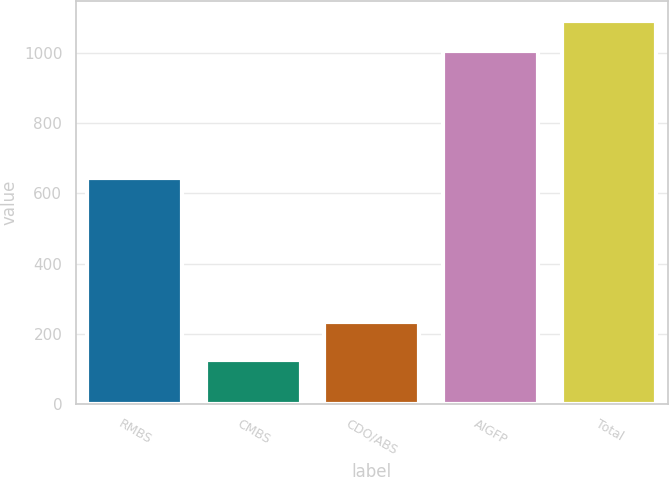<chart> <loc_0><loc_0><loc_500><loc_500><bar_chart><fcel>RMBS<fcel>CMBS<fcel>CDO/ABS<fcel>AIGFP<fcel>Total<nl><fcel>645<fcel>126<fcel>233<fcel>1004<fcel>1091.8<nl></chart> 